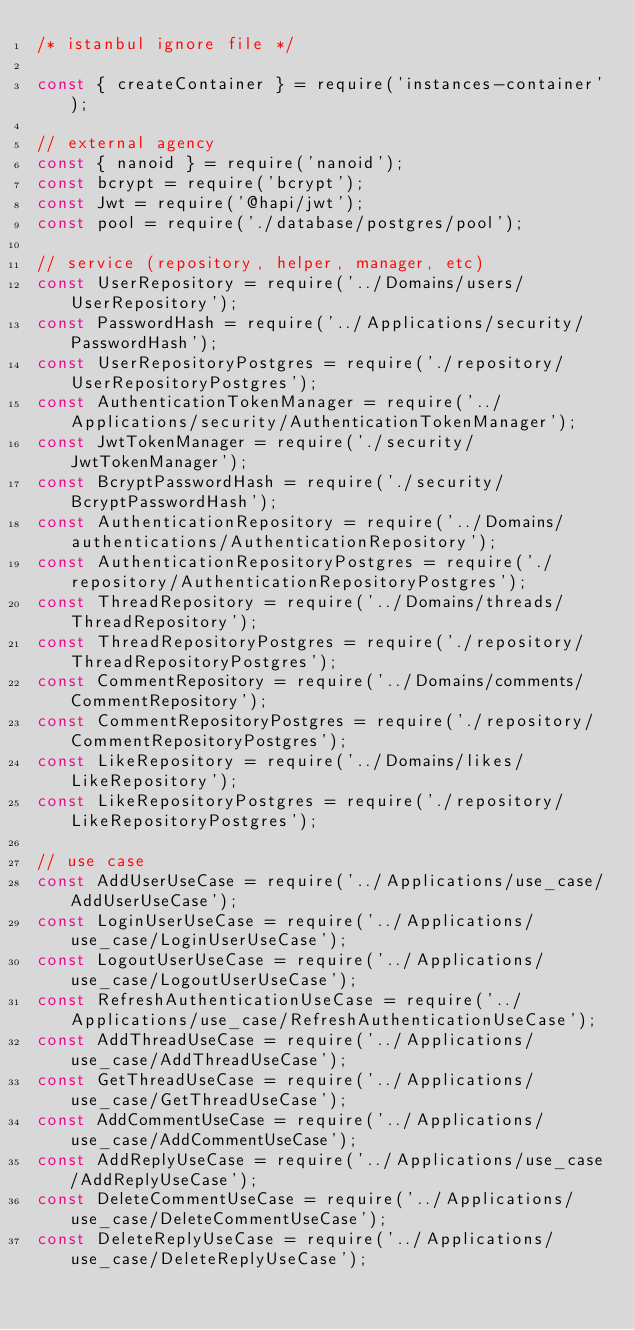Convert code to text. <code><loc_0><loc_0><loc_500><loc_500><_JavaScript_>/* istanbul ignore file */

const { createContainer } = require('instances-container');

// external agency
const { nanoid } = require('nanoid');
const bcrypt = require('bcrypt');
const Jwt = require('@hapi/jwt');
const pool = require('./database/postgres/pool');

// service (repository, helper, manager, etc)
const UserRepository = require('../Domains/users/UserRepository');
const PasswordHash = require('../Applications/security/PasswordHash');
const UserRepositoryPostgres = require('./repository/UserRepositoryPostgres');
const AuthenticationTokenManager = require('../Applications/security/AuthenticationTokenManager');
const JwtTokenManager = require('./security/JwtTokenManager');
const BcryptPasswordHash = require('./security/BcryptPasswordHash');
const AuthenticationRepository = require('../Domains/authentications/AuthenticationRepository');
const AuthenticationRepositoryPostgres = require('./repository/AuthenticationRepositoryPostgres');
const ThreadRepository = require('../Domains/threads/ThreadRepository');
const ThreadRepositoryPostgres = require('./repository/ThreadRepositoryPostgres');
const CommentRepository = require('../Domains/comments/CommentRepository');
const CommentRepositoryPostgres = require('./repository/CommentRepositoryPostgres');
const LikeRepository = require('../Domains/likes/LikeRepository');
const LikeRepositoryPostgres = require('./repository/LikeRepositoryPostgres');

// use case
const AddUserUseCase = require('../Applications/use_case/AddUserUseCase');
const LoginUserUseCase = require('../Applications/use_case/LoginUserUseCase');
const LogoutUserUseCase = require('../Applications/use_case/LogoutUserUseCase');
const RefreshAuthenticationUseCase = require('../Applications/use_case/RefreshAuthenticationUseCase');
const AddThreadUseCase = require('../Applications/use_case/AddThreadUseCase');
const GetThreadUseCase = require('../Applications/use_case/GetThreadUseCase');
const AddCommentUseCase = require('../Applications/use_case/AddCommentUseCase');
const AddReplyUseCase = require('../Applications/use_case/AddReplyUseCase');
const DeleteCommentUseCase = require('../Applications/use_case/DeleteCommentUseCase');
const DeleteReplyUseCase = require('../Applications/use_case/DeleteReplyUseCase');</code> 